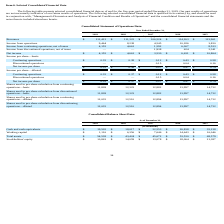From Travelzoo's financial document, What are the values of revenue for years ended December 31, 2019 to 2015 respectively? The document contains multiple relevant values: $111,412, $111,322, $106,524, $114,263, $123,961 (in thousands). From the document: "Revenues $ 111,412 $ 111,322 $ 106,524 $ 114,263 $ 123,961 evenues $ 111,412 $ 111,322 $ 106,524 $ 114,263 $ 123,961 Revenues $ 111,412 $ 111,322 $ 10..." Also, What are the values of income from operations for years ended December 31, 2019 to 2015 respectively? The document contains multiple relevant values: 9,464, 8,238, 4,545, 10,186, 3,820 (in thousands). From the document: "Income from operations 9,464 8,238 4,545 10,186 3,820 Income from operations 9,464 8,238 4,545 10,186 3,820 Income from operations 9,464 8,238 4,545 1..." Also, What does the table show? selected consolidated financial data as of and for the five-year period ended December 31, 2019. The document states: "The following table presents selected consolidated financial data as of and for the five-year period ended December 31, 2019. Our past results of oper..." Also, can you calculate: What is the difference in revenue amount between 2019 and 2018? Based on the calculation: 111,412 - 111,322 , the result is 90 (in thousands). This is based on the information: "Revenues $ 111,412 $ 111,322 $ 106,524 $ 114,263 $ 123,961 Revenues $ 111,412 $ 111,322 $ 106,524 $ 114,263 $ 123,961..." The key data points involved are: 111,322, 111,412. Also, can you calculate: What is the average net income per share for basic shares from 2015 to 2019? To answer this question, I need to perform calculations using the financial data. The calculation is: (0.35+0.38+0.27+0.47+0.74)/5, which equals 0.44. This is based on the information: "Net income per share $ 0.35 $ 0.38 $ 0.27 $ 0.47 $ 0.74 Continuing operations $ 0.35 $ 0.38 $ 0.12 $ 0.43 $ 0.58 et income per share $ 0.35 $ 0.38 $ 0.27 $ 0.47 $ 0.74 Net income per share $ 0.35 $ 0...." The key data points involved are: 0.27, 0.35, 0.38. Also, can you calculate: What is the percentage change of income from operations between 2018 to 2019? To answer this question, I need to perform calculations using the financial data. The calculation is: (9,464-8,238)/8,238, which equals 14.88 (percentage). This is based on the information: "Income from operations 9,464 8,238 4,545 10,186 3,820 Income from operations 9,464 8,238 4,545 10,186 3,820..." The key data points involved are: 8,238, 9,464. 